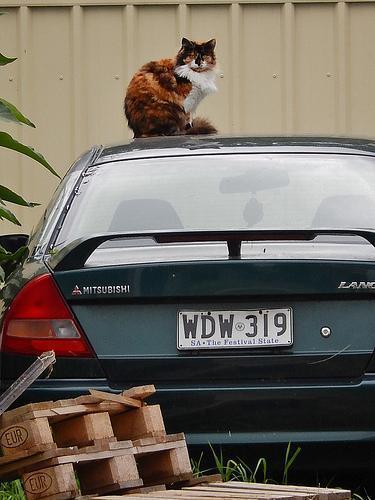How many license plates are there?
Give a very brief answer. 1. 